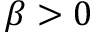Convert formula to latex. <formula><loc_0><loc_0><loc_500><loc_500>\beta > 0</formula> 